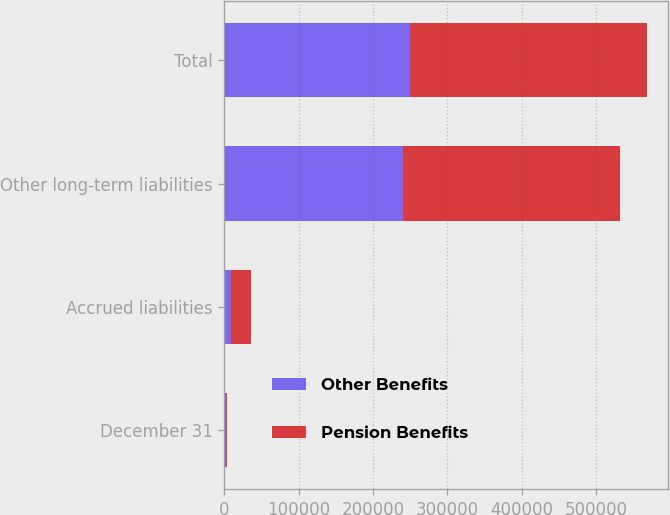Convert chart to OTSL. <chart><loc_0><loc_0><loc_500><loc_500><stacked_bar_chart><ecel><fcel>December 31<fcel>Accrued liabilities<fcel>Other long-term liabilities<fcel>Total<nl><fcel>Other Benefits<fcel>2012<fcel>9396<fcel>240215<fcel>249611<nl><fcel>Pension Benefits<fcel>2012<fcel>26181<fcel>292234<fcel>318415<nl></chart> 